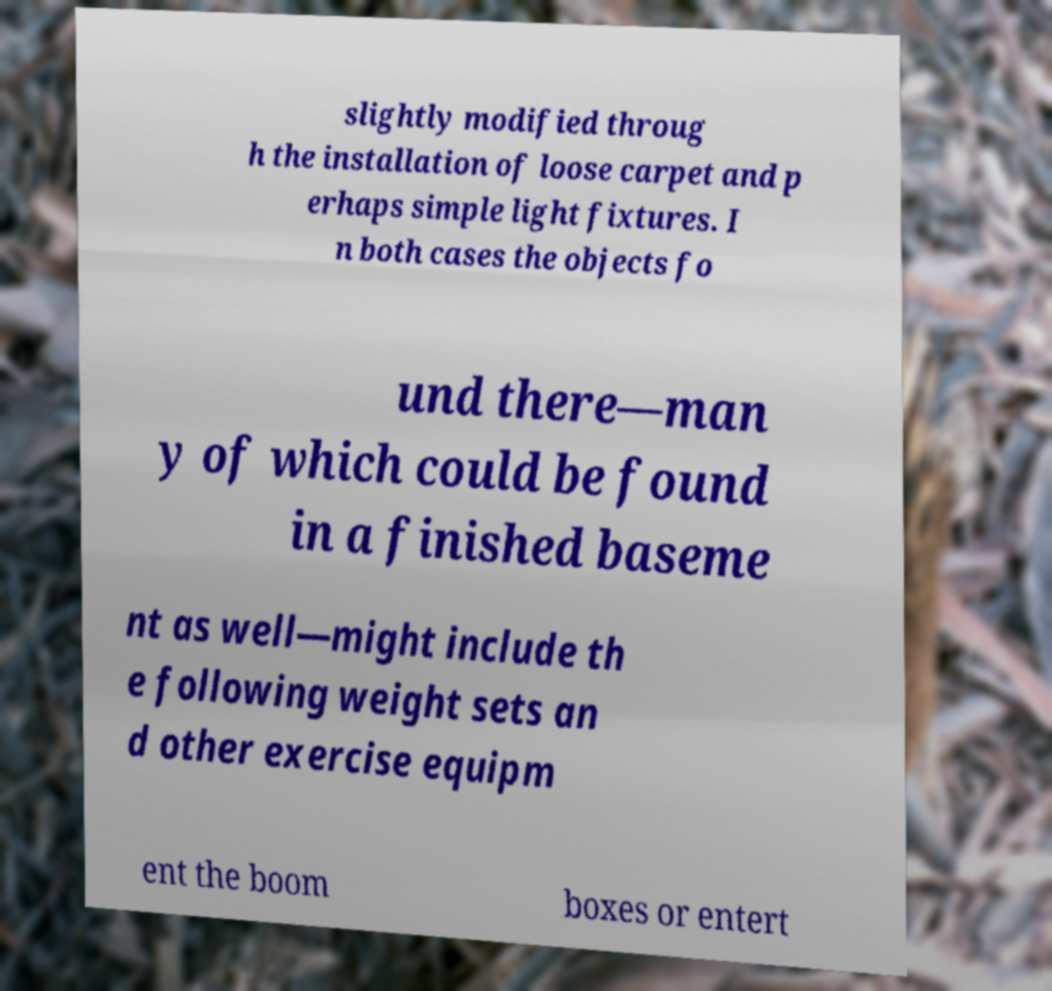I need the written content from this picture converted into text. Can you do that? slightly modified throug h the installation of loose carpet and p erhaps simple light fixtures. I n both cases the objects fo und there—man y of which could be found in a finished baseme nt as well—might include th e following weight sets an d other exercise equipm ent the boom boxes or entert 